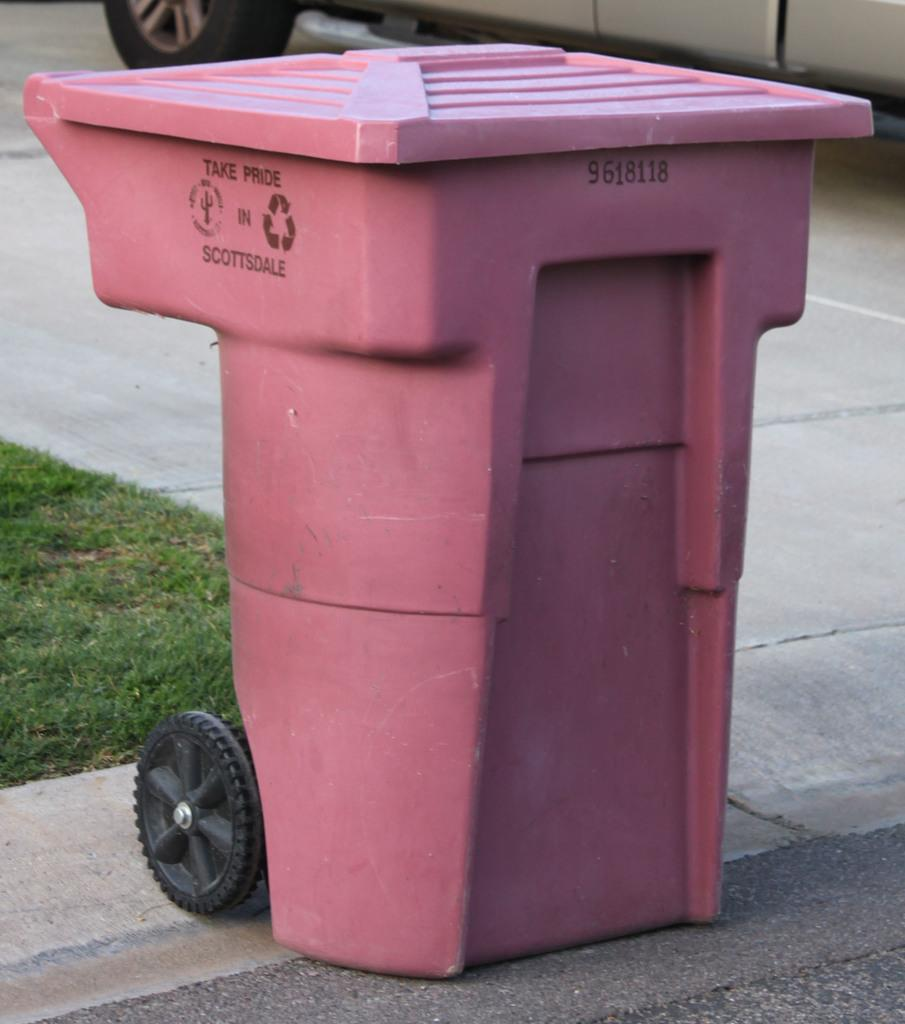<image>
Render a clear and concise summary of the photo. A pink recycling bin from Scottsdale is located on the side of the road next to a curb. 